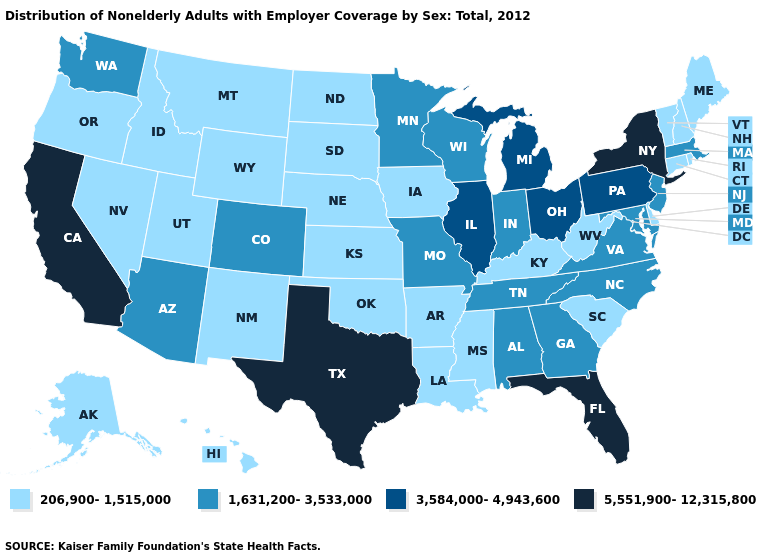What is the value of Minnesota?
Answer briefly. 1,631,200-3,533,000. What is the value of Maine?
Quick response, please. 206,900-1,515,000. Name the states that have a value in the range 206,900-1,515,000?
Write a very short answer. Alaska, Arkansas, Connecticut, Delaware, Hawaii, Idaho, Iowa, Kansas, Kentucky, Louisiana, Maine, Mississippi, Montana, Nebraska, Nevada, New Hampshire, New Mexico, North Dakota, Oklahoma, Oregon, Rhode Island, South Carolina, South Dakota, Utah, Vermont, West Virginia, Wyoming. Does Delaware have the same value as Tennessee?
Concise answer only. No. What is the value of South Carolina?
Concise answer only. 206,900-1,515,000. Name the states that have a value in the range 206,900-1,515,000?
Quick response, please. Alaska, Arkansas, Connecticut, Delaware, Hawaii, Idaho, Iowa, Kansas, Kentucky, Louisiana, Maine, Mississippi, Montana, Nebraska, Nevada, New Hampshire, New Mexico, North Dakota, Oklahoma, Oregon, Rhode Island, South Carolina, South Dakota, Utah, Vermont, West Virginia, Wyoming. What is the highest value in the South ?
Give a very brief answer. 5,551,900-12,315,800. Name the states that have a value in the range 1,631,200-3,533,000?
Short answer required. Alabama, Arizona, Colorado, Georgia, Indiana, Maryland, Massachusetts, Minnesota, Missouri, New Jersey, North Carolina, Tennessee, Virginia, Washington, Wisconsin. Which states hav the highest value in the South?
Give a very brief answer. Florida, Texas. Name the states that have a value in the range 5,551,900-12,315,800?
Answer briefly. California, Florida, New York, Texas. What is the lowest value in the USA?
Concise answer only. 206,900-1,515,000. What is the highest value in states that border Kentucky?
Quick response, please. 3,584,000-4,943,600. Name the states that have a value in the range 5,551,900-12,315,800?
Be succinct. California, Florida, New York, Texas. What is the lowest value in the West?
Write a very short answer. 206,900-1,515,000. Name the states that have a value in the range 206,900-1,515,000?
Be succinct. Alaska, Arkansas, Connecticut, Delaware, Hawaii, Idaho, Iowa, Kansas, Kentucky, Louisiana, Maine, Mississippi, Montana, Nebraska, Nevada, New Hampshire, New Mexico, North Dakota, Oklahoma, Oregon, Rhode Island, South Carolina, South Dakota, Utah, Vermont, West Virginia, Wyoming. 